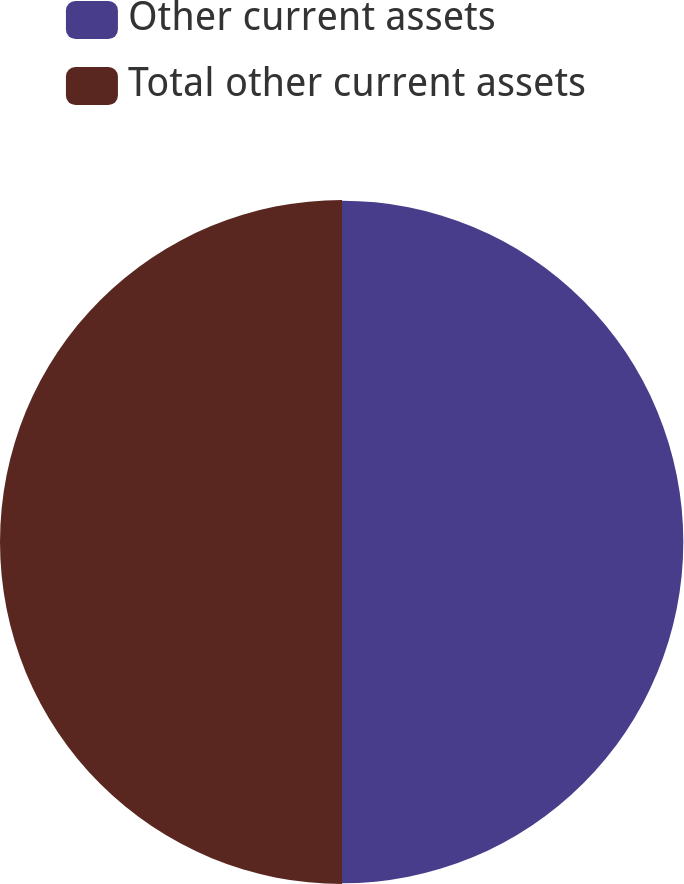<chart> <loc_0><loc_0><loc_500><loc_500><pie_chart><fcel>Other current assets<fcel>Total other current assets<nl><fcel>49.95%<fcel>50.05%<nl></chart> 